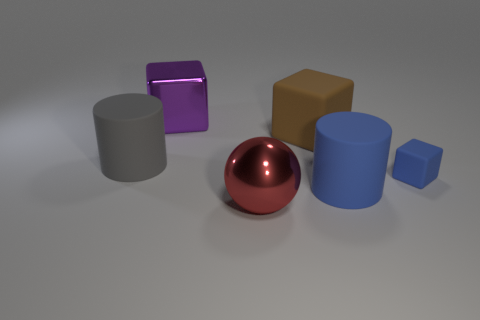The cylinder that is the same color as the small matte thing is what size?
Keep it short and to the point. Large. The rubber thing that is the same color as the small matte block is what shape?
Offer a very short reply. Cylinder. Is there anything else of the same color as the small thing?
Offer a very short reply. Yes. The metallic cube has what color?
Provide a succinct answer. Purple. There is a large purple shiny block; are there any big gray cylinders in front of it?
Provide a short and direct response. Yes. Do the purple thing and the blue rubber object that is behind the blue rubber cylinder have the same shape?
Give a very brief answer. Yes. What number of other objects are there of the same material as the ball?
Give a very brief answer. 1. What color is the big rubber cylinder that is on the right side of the matte thing on the left side of the large metal object to the left of the big red metallic thing?
Your answer should be very brief. Blue. The large metal object in front of the matte block that is behind the gray cylinder is what shape?
Provide a succinct answer. Sphere. Are there more brown matte blocks that are in front of the purple thing than tiny purple blocks?
Provide a succinct answer. Yes. 